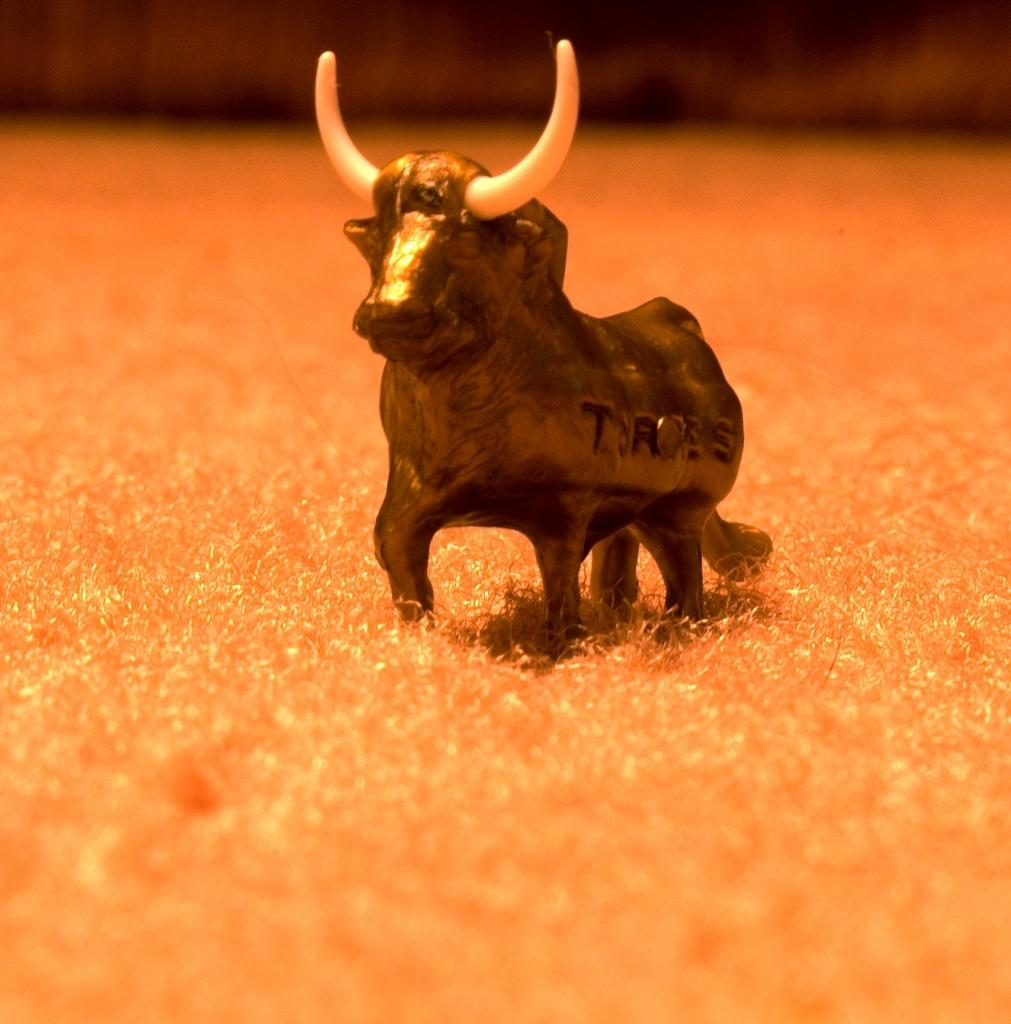What is the main subject of the image? There is a toy in the center of the image. What verse is being recited by the toy in the image? There is no verse being recited by the toy in the image, as it is a toy and not capable of reciting verses. 